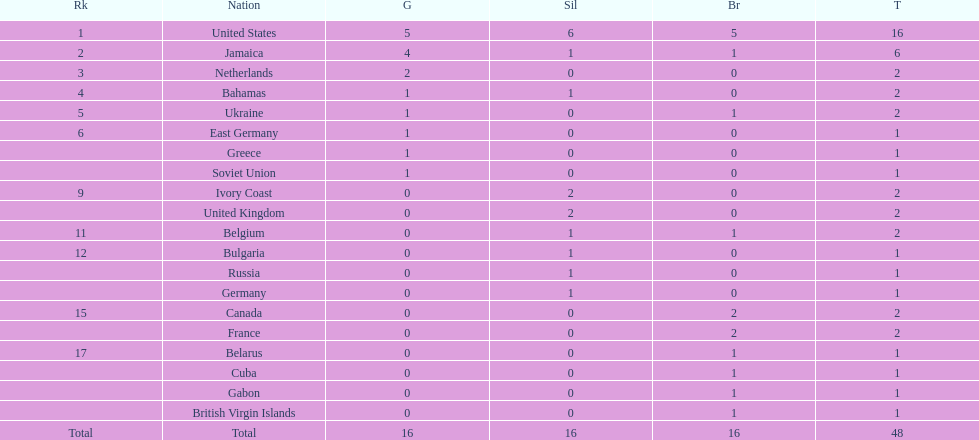Can you give me this table as a dict? {'header': ['Rk', 'Nation', 'G', 'Sil', 'Br', 'T'], 'rows': [['1', 'United States', '5', '6', '5', '16'], ['2', 'Jamaica', '4', '1', '1', '6'], ['3', 'Netherlands', '2', '0', '0', '2'], ['4', 'Bahamas', '1', '1', '0', '2'], ['5', 'Ukraine', '1', '0', '1', '2'], ['6', 'East Germany', '1', '0', '0', '1'], ['', 'Greece', '1', '0', '0', '1'], ['', 'Soviet Union', '1', '0', '0', '1'], ['9', 'Ivory Coast', '0', '2', '0', '2'], ['', 'United Kingdom', '0', '2', '0', '2'], ['11', 'Belgium', '0', '1', '1', '2'], ['12', 'Bulgaria', '0', '1', '0', '1'], ['', 'Russia', '0', '1', '0', '1'], ['', 'Germany', '0', '1', '0', '1'], ['15', 'Canada', '0', '0', '2', '2'], ['', 'France', '0', '0', '2', '2'], ['17', 'Belarus', '0', '0', '1', '1'], ['', 'Cuba', '0', '0', '1', '1'], ['', 'Gabon', '0', '0', '1', '1'], ['', 'British Virgin Islands', '0', '0', '1', '1'], ['Total', 'Total', '16', '16', '16', '48']]} How many gold medals did the us and jamaica win combined? 9. 